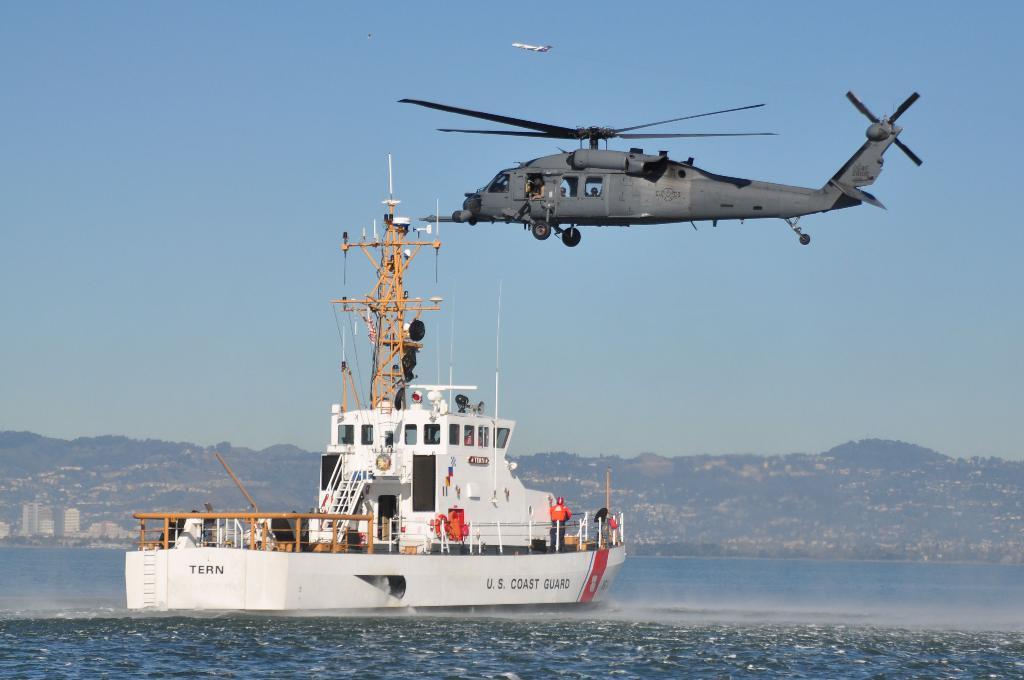Could you give a brief overview of what you see in this image? In this image at the bottom there is an ocean in the ocean there is one ship, in that ship there are some people and on the top of the image there is a helicopter. In the background there are some mountains, buildings and trees. On the top of the image there is sky. 